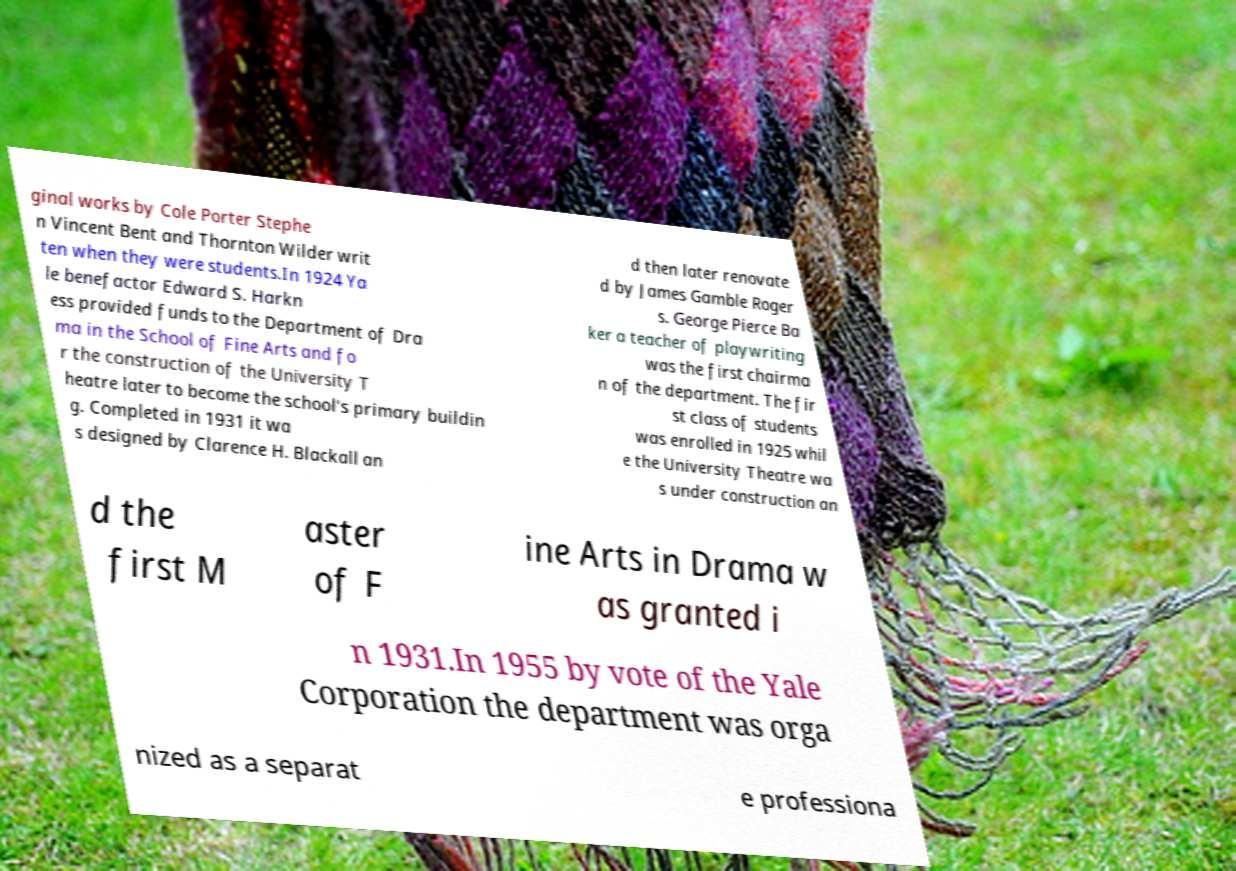What messages or text are displayed in this image? I need them in a readable, typed format. ginal works by Cole Porter Stephe n Vincent Bent and Thornton Wilder writ ten when they were students.In 1924 Ya le benefactor Edward S. Harkn ess provided funds to the Department of Dra ma in the School of Fine Arts and fo r the construction of the University T heatre later to become the school's primary buildin g. Completed in 1931 it wa s designed by Clarence H. Blackall an d then later renovate d by James Gamble Roger s. George Pierce Ba ker a teacher of playwriting was the first chairma n of the department. The fir st class of students was enrolled in 1925 whil e the University Theatre wa s under construction an d the first M aster of F ine Arts in Drama w as granted i n 1931.In 1955 by vote of the Yale Corporation the department was orga nized as a separat e professiona 